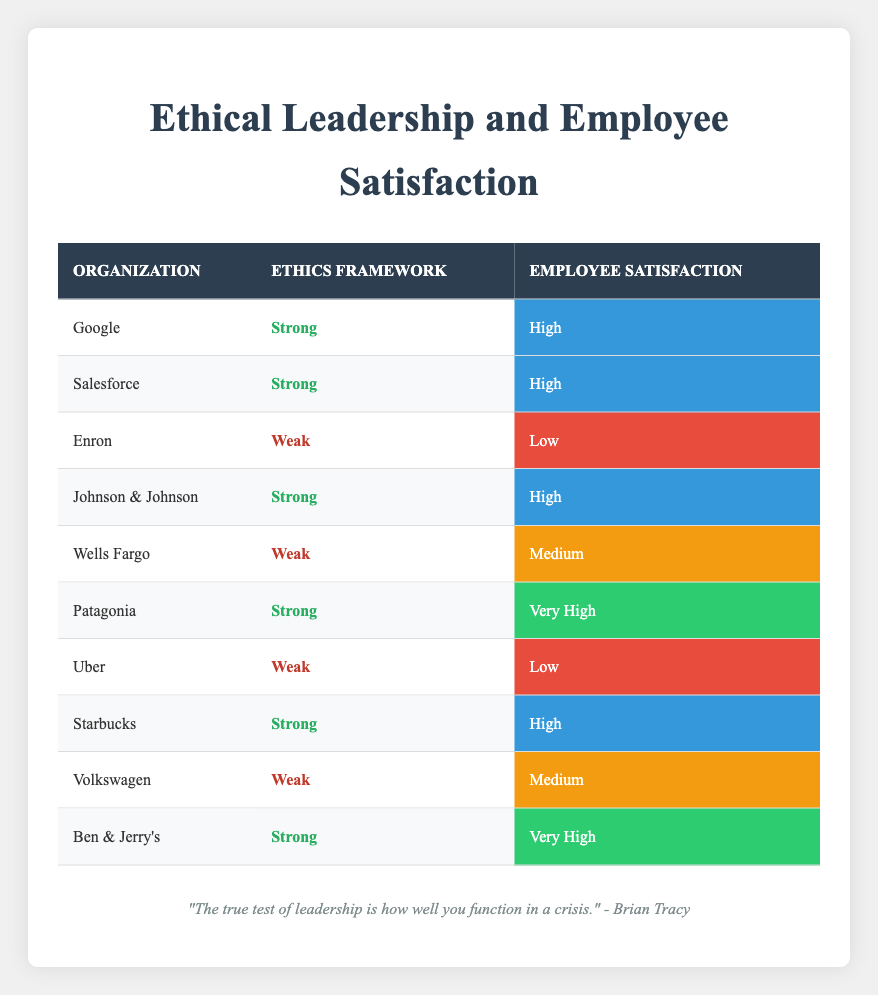Which organizations have a strong ethical framework and high employee satisfaction? From the table, we can look for rows where the ethics framework is marked as "Strong" and the employee satisfaction is marked as "High." The organizations that fit this criterion are Google, Salesforce, Johnson & Johnson, and Starbucks.
Answer: Google, Salesforce, Johnson & Johnson, Starbucks What is the employee satisfaction level for Patagonia? By checking the table, we find Patagonia, which is listed under strong ethical frameworks. Its corresponding employee satisfaction level is marked as "Very High."
Answer: Very High Is it true that all organizations with a weak ethical framework have low employee satisfaction? Reviewing the table shows that not all organizations with a weak ethical framework have low employee satisfaction. For example, Wells Fargo and Volkswagen both have a weak ethical framework and their employee satisfaction levels are "Medium." Therefore, the statement is false.
Answer: No How many organizations exhibit a "Very High" level of employee satisfaction? To determine this, we count the number of organizations in the table that are noted as having "Very High" employee satisfaction. These organizations are Patagonia and Ben & Jerry's, resulting in a total of two.
Answer: 2 What is the average employee satisfaction level for organizations with a strong ethical framework? First, we identify the satisfaction levels corresponding to organizations with a strong ethical framework: Very High (Patagonia), Very High (Ben & Jerry's), High (Google), High (Salesforce), High (Johnson & Johnson), and High (Starbucks). Converting these to a numeric scale (Very High = 4, High = 3), we have 4, 4, 3, 3, 3, 3, which sums to 20. There are 6 data points, so the average is 20/6 ≈ 3.33, which corresponds to "High."
Answer: High Which organization with a weak ethical framework has the highest employee satisfaction level? We find the organizations with a weak ethical framework: Enron (Low), Wells Fargo (Medium), Uber (Low), and Volkswagen (Medium). The highest employee satisfaction among these is Medium, which is held by both Wells Fargo and Volkswagen.
Answer: Wells Fargo and Volkswagen 